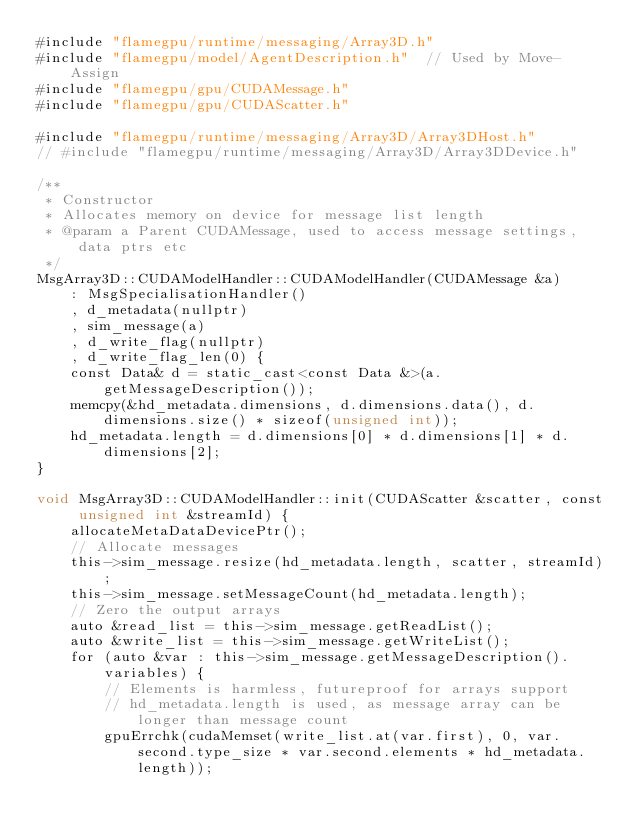Convert code to text. <code><loc_0><loc_0><loc_500><loc_500><_Cuda_>#include "flamegpu/runtime/messaging/Array3D.h"
#include "flamegpu/model/AgentDescription.h"  // Used by Move-Assign
#include "flamegpu/gpu/CUDAMessage.h"
#include "flamegpu/gpu/CUDAScatter.h"

#include "flamegpu/runtime/messaging/Array3D/Array3DHost.h"
// #include "flamegpu/runtime/messaging/Array3D/Array3DDevice.h"

/**
 * Constructor
 * Allocates memory on device for message list length
 * @param a Parent CUDAMessage, used to access message settings, data ptrs etc
 */
MsgArray3D::CUDAModelHandler::CUDAModelHandler(CUDAMessage &a)
    : MsgSpecialisationHandler()
    , d_metadata(nullptr)
    , sim_message(a)
    , d_write_flag(nullptr)
    , d_write_flag_len(0) {
    const Data& d = static_cast<const Data &>(a.getMessageDescription());
    memcpy(&hd_metadata.dimensions, d.dimensions.data(), d.dimensions.size() * sizeof(unsigned int));
    hd_metadata.length = d.dimensions[0] * d.dimensions[1] * d.dimensions[2];
}

void MsgArray3D::CUDAModelHandler::init(CUDAScatter &scatter, const unsigned int &streamId) {
    allocateMetaDataDevicePtr();
    // Allocate messages
    this->sim_message.resize(hd_metadata.length, scatter, streamId);
    this->sim_message.setMessageCount(hd_metadata.length);
    // Zero the output arrays
    auto &read_list = this->sim_message.getReadList();
    auto &write_list = this->sim_message.getWriteList();
    for (auto &var : this->sim_message.getMessageDescription().variables) {
        // Elements is harmless, futureproof for arrays support
        // hd_metadata.length is used, as message array can be longer than message count
        gpuErrchk(cudaMemset(write_list.at(var.first), 0, var.second.type_size * var.second.elements * hd_metadata.length));</code> 